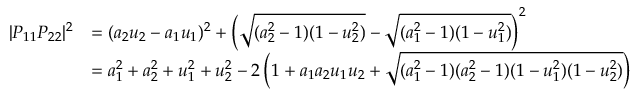<formula> <loc_0><loc_0><loc_500><loc_500>{ \begin{array} { r l } { | P _ { 1 1 } P _ { 2 2 } | ^ { 2 } } & { = ( a _ { 2 } u _ { 2 } - a _ { 1 } u _ { 1 } ) ^ { 2 } + \left ( { \sqrt { ( a _ { 2 } ^ { 2 } - 1 ) ( 1 - u _ { 2 } ^ { 2 } ) } } - { \sqrt { ( a _ { 1 } ^ { 2 } - 1 ) ( 1 - u _ { 1 } ^ { 2 } ) } } \right ) ^ { 2 } } \\ & { = a _ { 1 } ^ { 2 } + a _ { 2 } ^ { 2 } + u _ { 1 } ^ { 2 } + u _ { 2 } ^ { 2 } - 2 \left ( 1 + a _ { 1 } a _ { 2 } u _ { 1 } u _ { 2 } + { \sqrt { ( a _ { 1 } ^ { 2 } - 1 ) ( a _ { 2 } ^ { 2 } - 1 ) ( 1 - u _ { 1 } ^ { 2 } ) ( 1 - u _ { 2 } ^ { 2 } ) } } \right ) } \end{array} }</formula> 